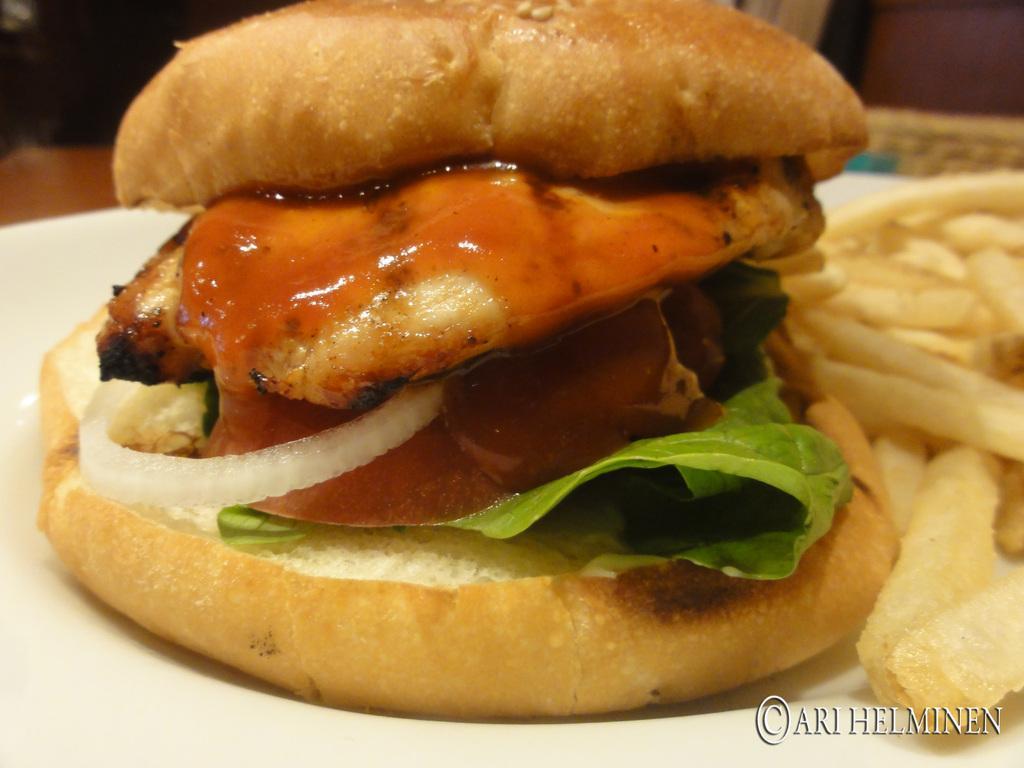Describe this image in one or two sentences. In this image at the bottom there is one plate and in the plate there is one burger and some french fries, in the background there are some objects. 